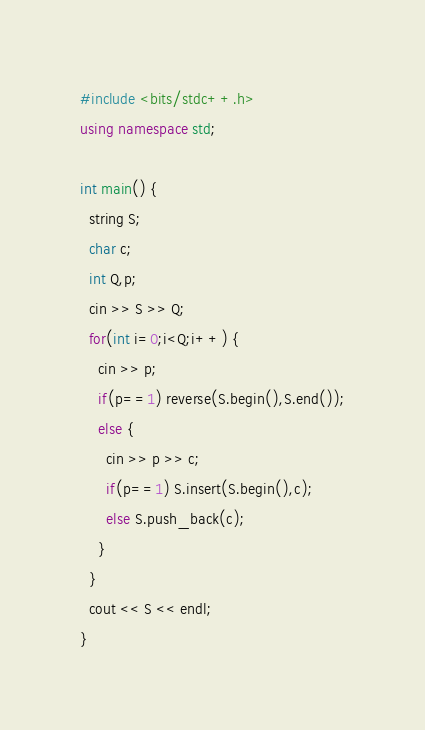<code> <loc_0><loc_0><loc_500><loc_500><_C++_>#include <bits/stdc++.h>
using namespace std;

int main() {
  string S;
  char c;
  int Q,p;
  cin >> S >> Q;
  for(int i=0;i<Q;i++) {
    cin >> p;
    if(p==1) reverse(S.begin(),S.end());
    else {
      cin >> p >> c;
      if(p==1) S.insert(S.begin(),c);
      else S.push_back(c);
    }
  }
  cout << S << endl;
}</code> 